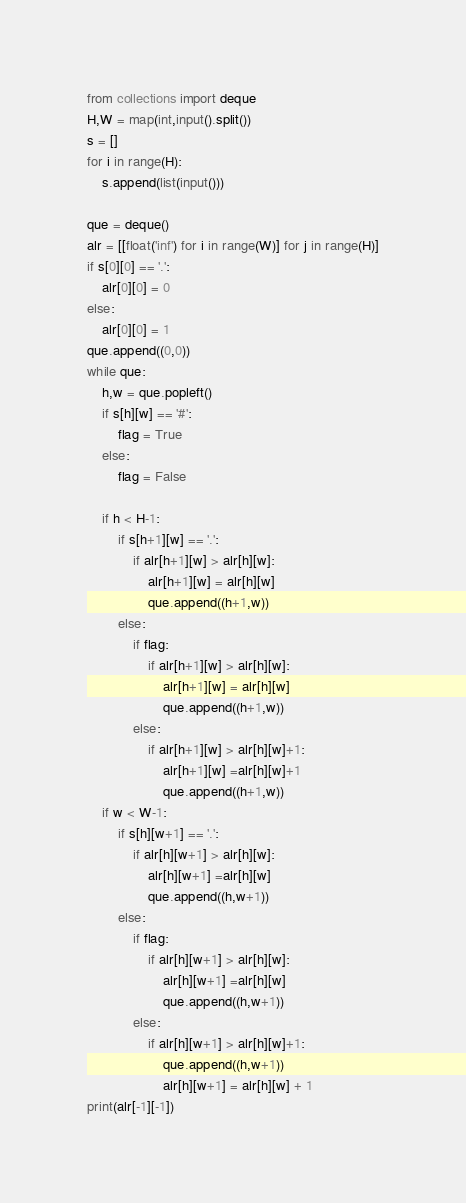<code> <loc_0><loc_0><loc_500><loc_500><_Python_>from collections import deque
H,W = map(int,input().split())
s = []
for i in range(H):
    s.append(list(input()))

que = deque()
alr = [[float('inf') for i in range(W)] for j in range(H)]
if s[0][0] == '.':
    alr[0][0] = 0
else:
    alr[0][0] = 1
que.append((0,0))
while que:
    h,w = que.popleft()
    if s[h][w] == '#':
        flag = True
    else:
        flag = False

    if h < H-1:
        if s[h+1][w] == '.':
            if alr[h+1][w] > alr[h][w]:
                alr[h+1][w] = alr[h][w]
                que.append((h+1,w))
        else:
            if flag:
                if alr[h+1][w] > alr[h][w]:
                    alr[h+1][w] = alr[h][w]
                    que.append((h+1,w))
            else:
                if alr[h+1][w] > alr[h][w]+1:
                    alr[h+1][w] =alr[h][w]+1
                    que.append((h+1,w))            
    if w < W-1:
        if s[h][w+1] == '.':
            if alr[h][w+1] > alr[h][w]:
                alr[h][w+1] =alr[h][w]
                que.append((h,w+1))
        else:
            if flag:
                if alr[h][w+1] > alr[h][w]:
                    alr[h][w+1] =alr[h][w]
                    que.append((h,w+1))
            else:
                if alr[h][w+1] > alr[h][w]+1:
                    que.append((h,w+1))
                    alr[h][w+1] = alr[h][w] + 1
print(alr[-1][-1])</code> 